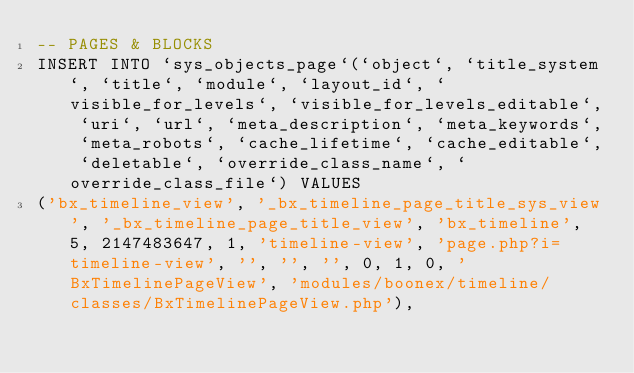<code> <loc_0><loc_0><loc_500><loc_500><_SQL_>-- PAGES & BLOCKS
INSERT INTO `sys_objects_page`(`object`, `title_system`, `title`, `module`, `layout_id`, `visible_for_levels`, `visible_for_levels_editable`, `uri`, `url`, `meta_description`, `meta_keywords`, `meta_robots`, `cache_lifetime`, `cache_editable`, `deletable`, `override_class_name`, `override_class_file`) VALUES 
('bx_timeline_view', '_bx_timeline_page_title_sys_view', '_bx_timeline_page_title_view', 'bx_timeline', 5, 2147483647, 1, 'timeline-view', 'page.php?i=timeline-view', '', '', '', 0, 1, 0, 'BxTimelinePageView', 'modules/boonex/timeline/classes/BxTimelinePageView.php'),</code> 